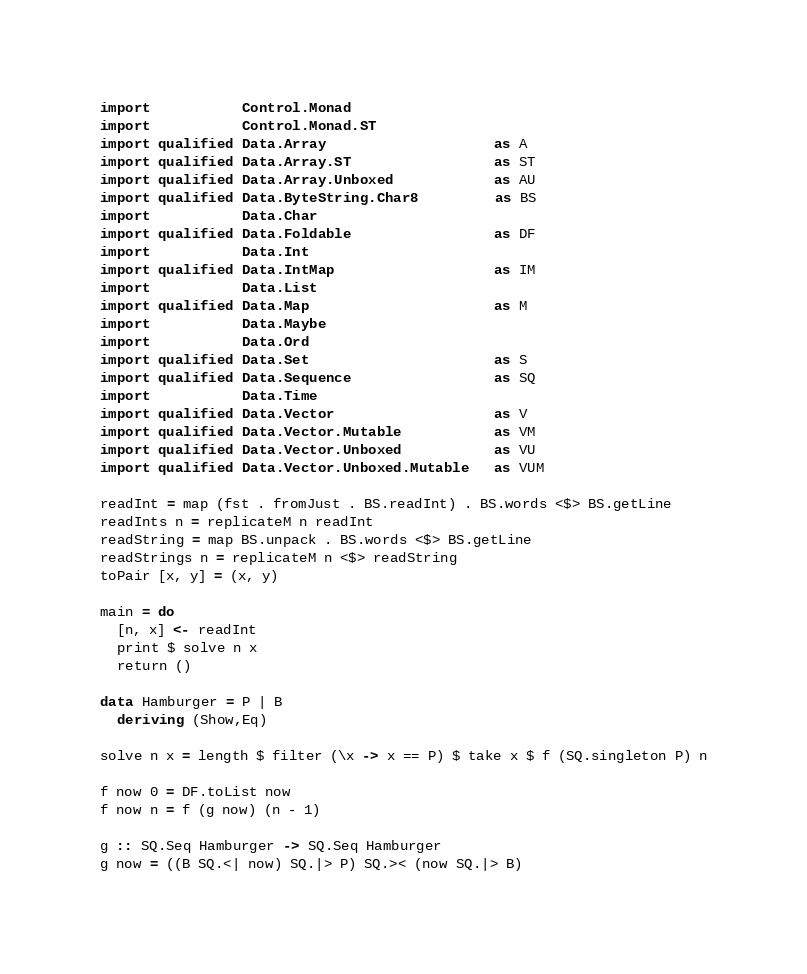Convert code to text. <code><loc_0><loc_0><loc_500><loc_500><_Haskell_>import           Control.Monad
import           Control.Monad.ST
import qualified Data.Array                    as A
import qualified Data.Array.ST                 as ST
import qualified Data.Array.Unboxed            as AU
import qualified Data.ByteString.Char8         as BS
import           Data.Char
import qualified Data.Foldable                 as DF
import           Data.Int
import qualified Data.IntMap                   as IM
import           Data.List
import qualified Data.Map                      as M
import           Data.Maybe
import           Data.Ord
import qualified Data.Set                      as S
import qualified Data.Sequence                 as SQ
import           Data.Time
import qualified Data.Vector                   as V
import qualified Data.Vector.Mutable           as VM
import qualified Data.Vector.Unboxed           as VU
import qualified Data.Vector.Unboxed.Mutable   as VUM

readInt = map (fst . fromJust . BS.readInt) . BS.words <$> BS.getLine
readInts n = replicateM n readInt
readString = map BS.unpack . BS.words <$> BS.getLine
readStrings n = replicateM n <$> readString
toPair [x, y] = (x, y)

main = do
  [n, x] <- readInt
  print $ solve n x
  return ()

data Hamburger = P | B
  deriving (Show,Eq)

solve n x = length $ filter (\x -> x == P) $ take x $ f (SQ.singleton P) n

f now 0 = DF.toList now
f now n = f (g now) (n - 1)

g :: SQ.Seq Hamburger -> SQ.Seq Hamburger
g now = ((B SQ.<| now) SQ.|> P) SQ.>< (now SQ.|> B)
</code> 